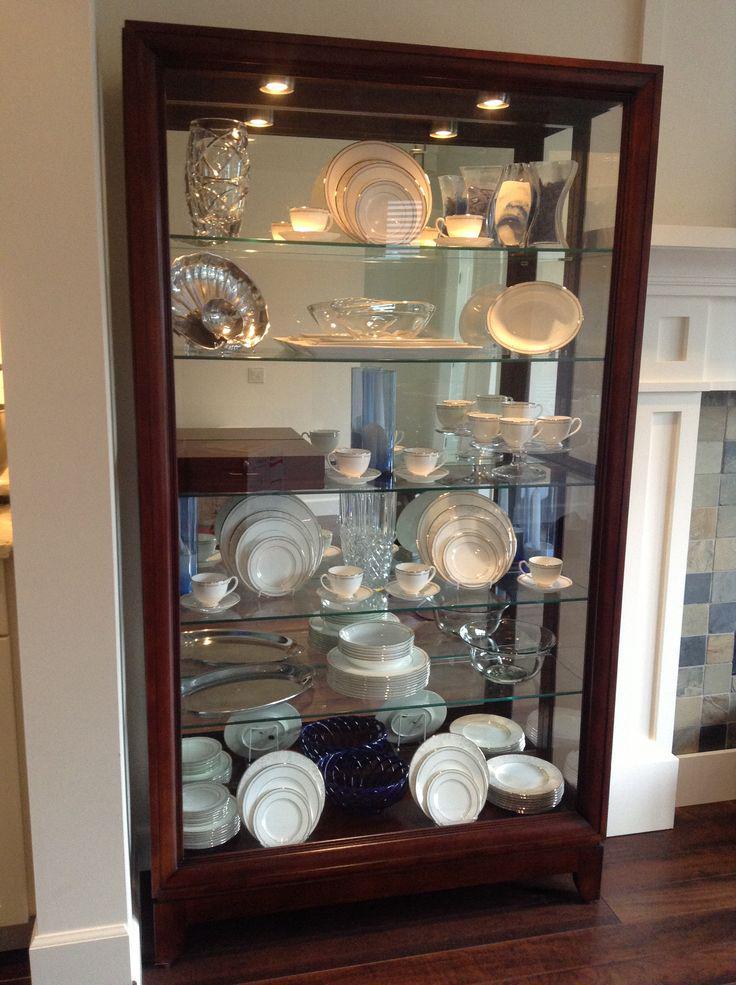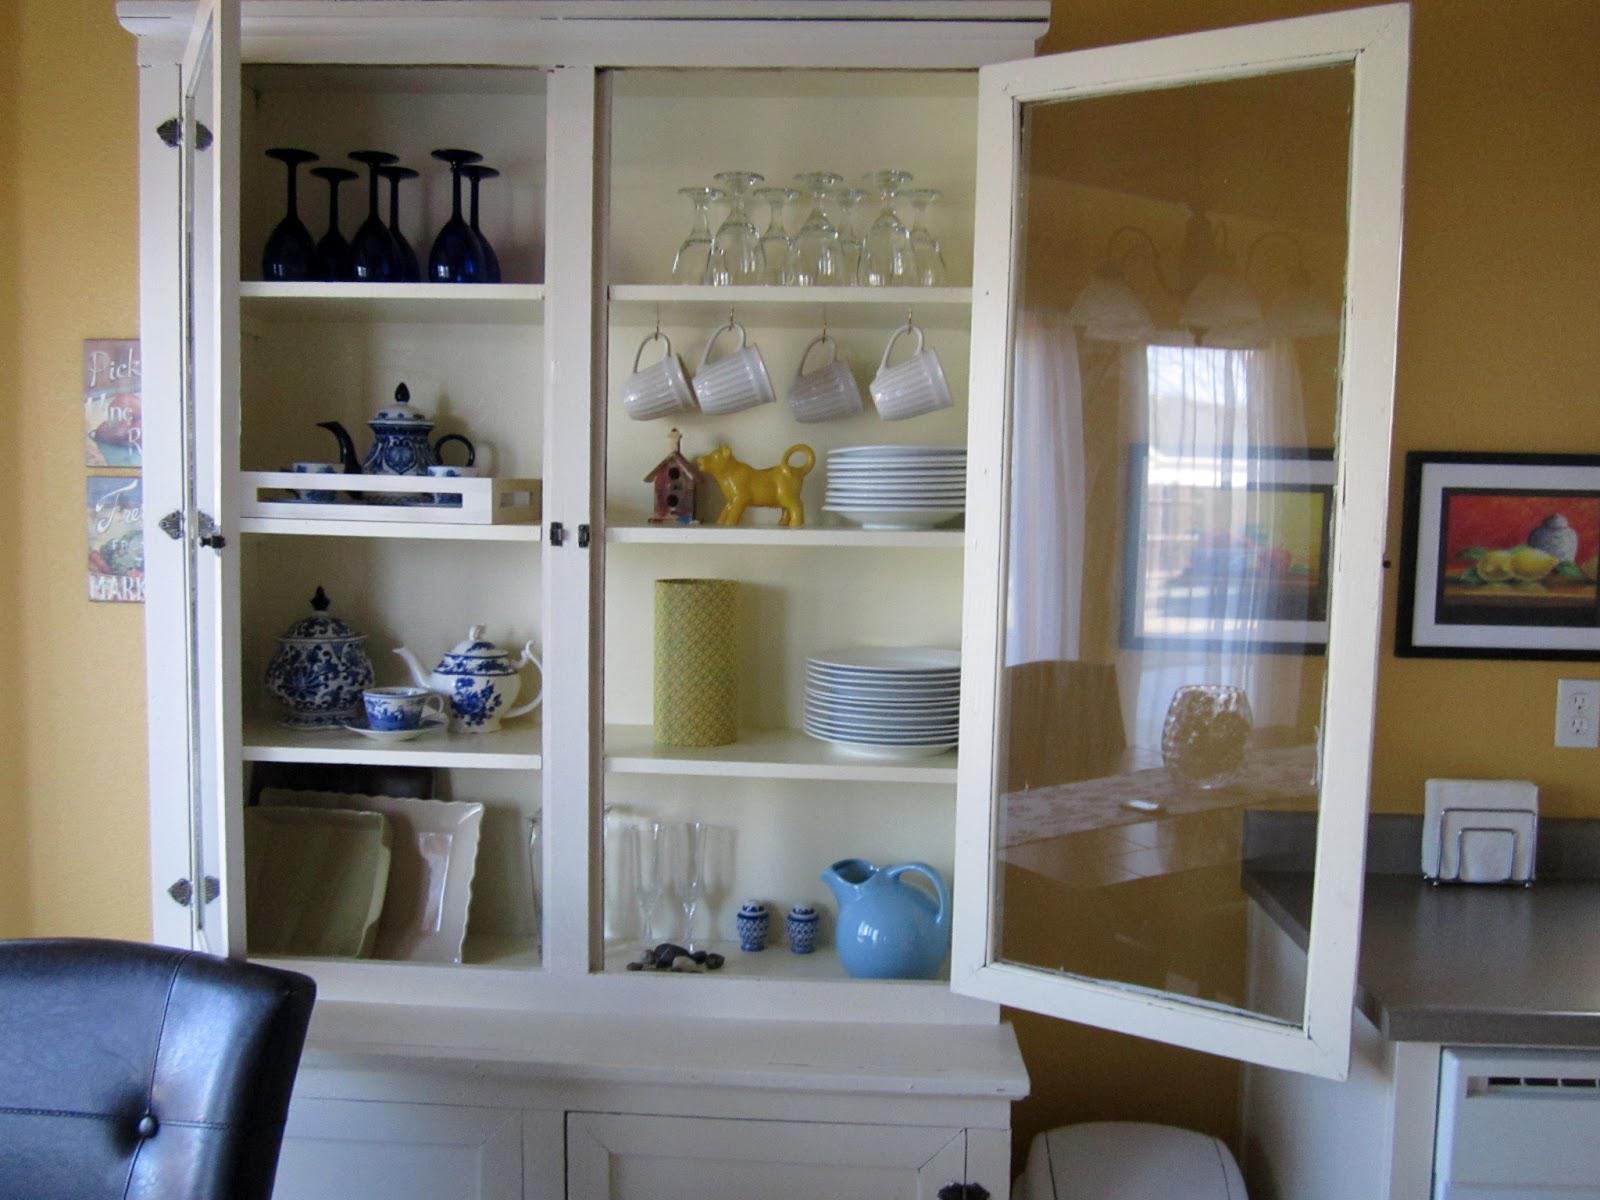The first image is the image on the left, the second image is the image on the right. For the images displayed, is the sentence "One cabinet is white with a pale blue interior and sculpted, non-flat top, and sits flush to the floor." factually correct? Answer yes or no. No. The first image is the image on the left, the second image is the image on the right. Evaluate the accuracy of this statement regarding the images: "There are two freestanding cabinets containing dishes.". Is it true? Answer yes or no. Yes. 